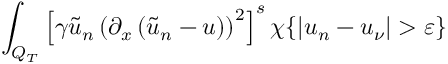Convert formula to latex. <formula><loc_0><loc_0><loc_500><loc_500>\int _ { Q _ { T } } \left [ \gamma \tilde { u } _ { n } \left ( \partial _ { x } \left ( \tilde { u } _ { n } - u \right ) \right ) ^ { 2 } \right ] ^ { s } \chi \{ | u _ { n } - u _ { \nu } | > \varepsilon \}</formula> 